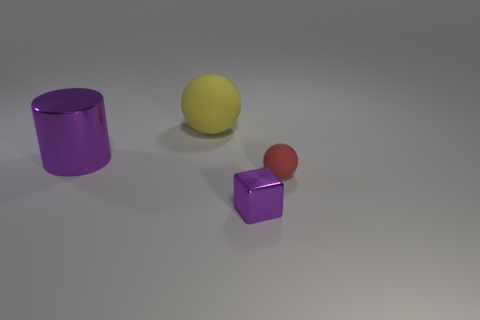How big is the yellow matte sphere?
Your response must be concise. Large. The tiny object that is made of the same material as the large sphere is what color?
Your answer should be very brief. Red. How many yellow matte objects have the same size as the purple cylinder?
Ensure brevity in your answer.  1. Is the material of the object left of the yellow rubber object the same as the yellow sphere?
Give a very brief answer. No. Are there fewer big purple metallic cylinders that are to the right of the small ball than big metallic cylinders?
Keep it short and to the point. Yes. What shape is the purple metallic object that is behind the small shiny block?
Keep it short and to the point. Cylinder. The purple metallic thing that is the same size as the red matte thing is what shape?
Your answer should be very brief. Cube. Are there any big cyan metallic things of the same shape as the tiny purple metallic object?
Provide a short and direct response. No. Is the shape of the tiny purple shiny object that is on the right side of the big yellow matte ball the same as the large thing that is left of the yellow thing?
Keep it short and to the point. No. There is another thing that is the same size as the red thing; what is it made of?
Make the answer very short. Metal. 